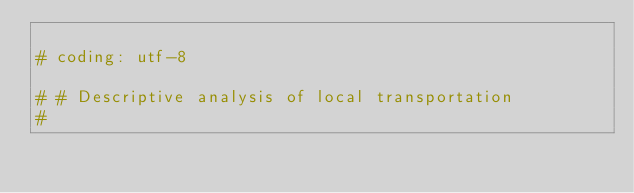<code> <loc_0><loc_0><loc_500><loc_500><_Python_>
# coding: utf-8

# # Descriptive analysis of local transportation
# 
</code> 